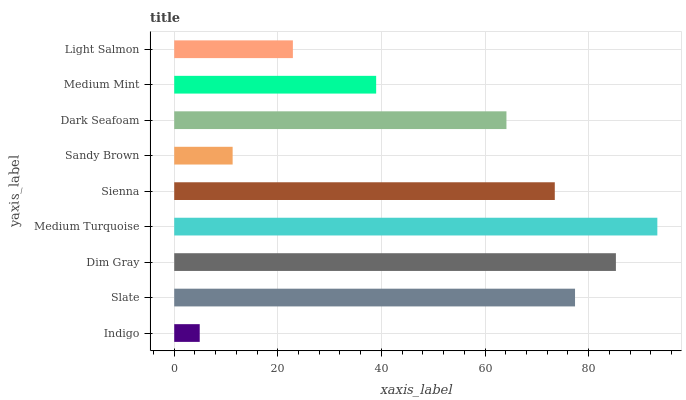Is Indigo the minimum?
Answer yes or no. Yes. Is Medium Turquoise the maximum?
Answer yes or no. Yes. Is Slate the minimum?
Answer yes or no. No. Is Slate the maximum?
Answer yes or no. No. Is Slate greater than Indigo?
Answer yes or no. Yes. Is Indigo less than Slate?
Answer yes or no. Yes. Is Indigo greater than Slate?
Answer yes or no. No. Is Slate less than Indigo?
Answer yes or no. No. Is Dark Seafoam the high median?
Answer yes or no. Yes. Is Dark Seafoam the low median?
Answer yes or no. Yes. Is Sienna the high median?
Answer yes or no. No. Is Light Salmon the low median?
Answer yes or no. No. 